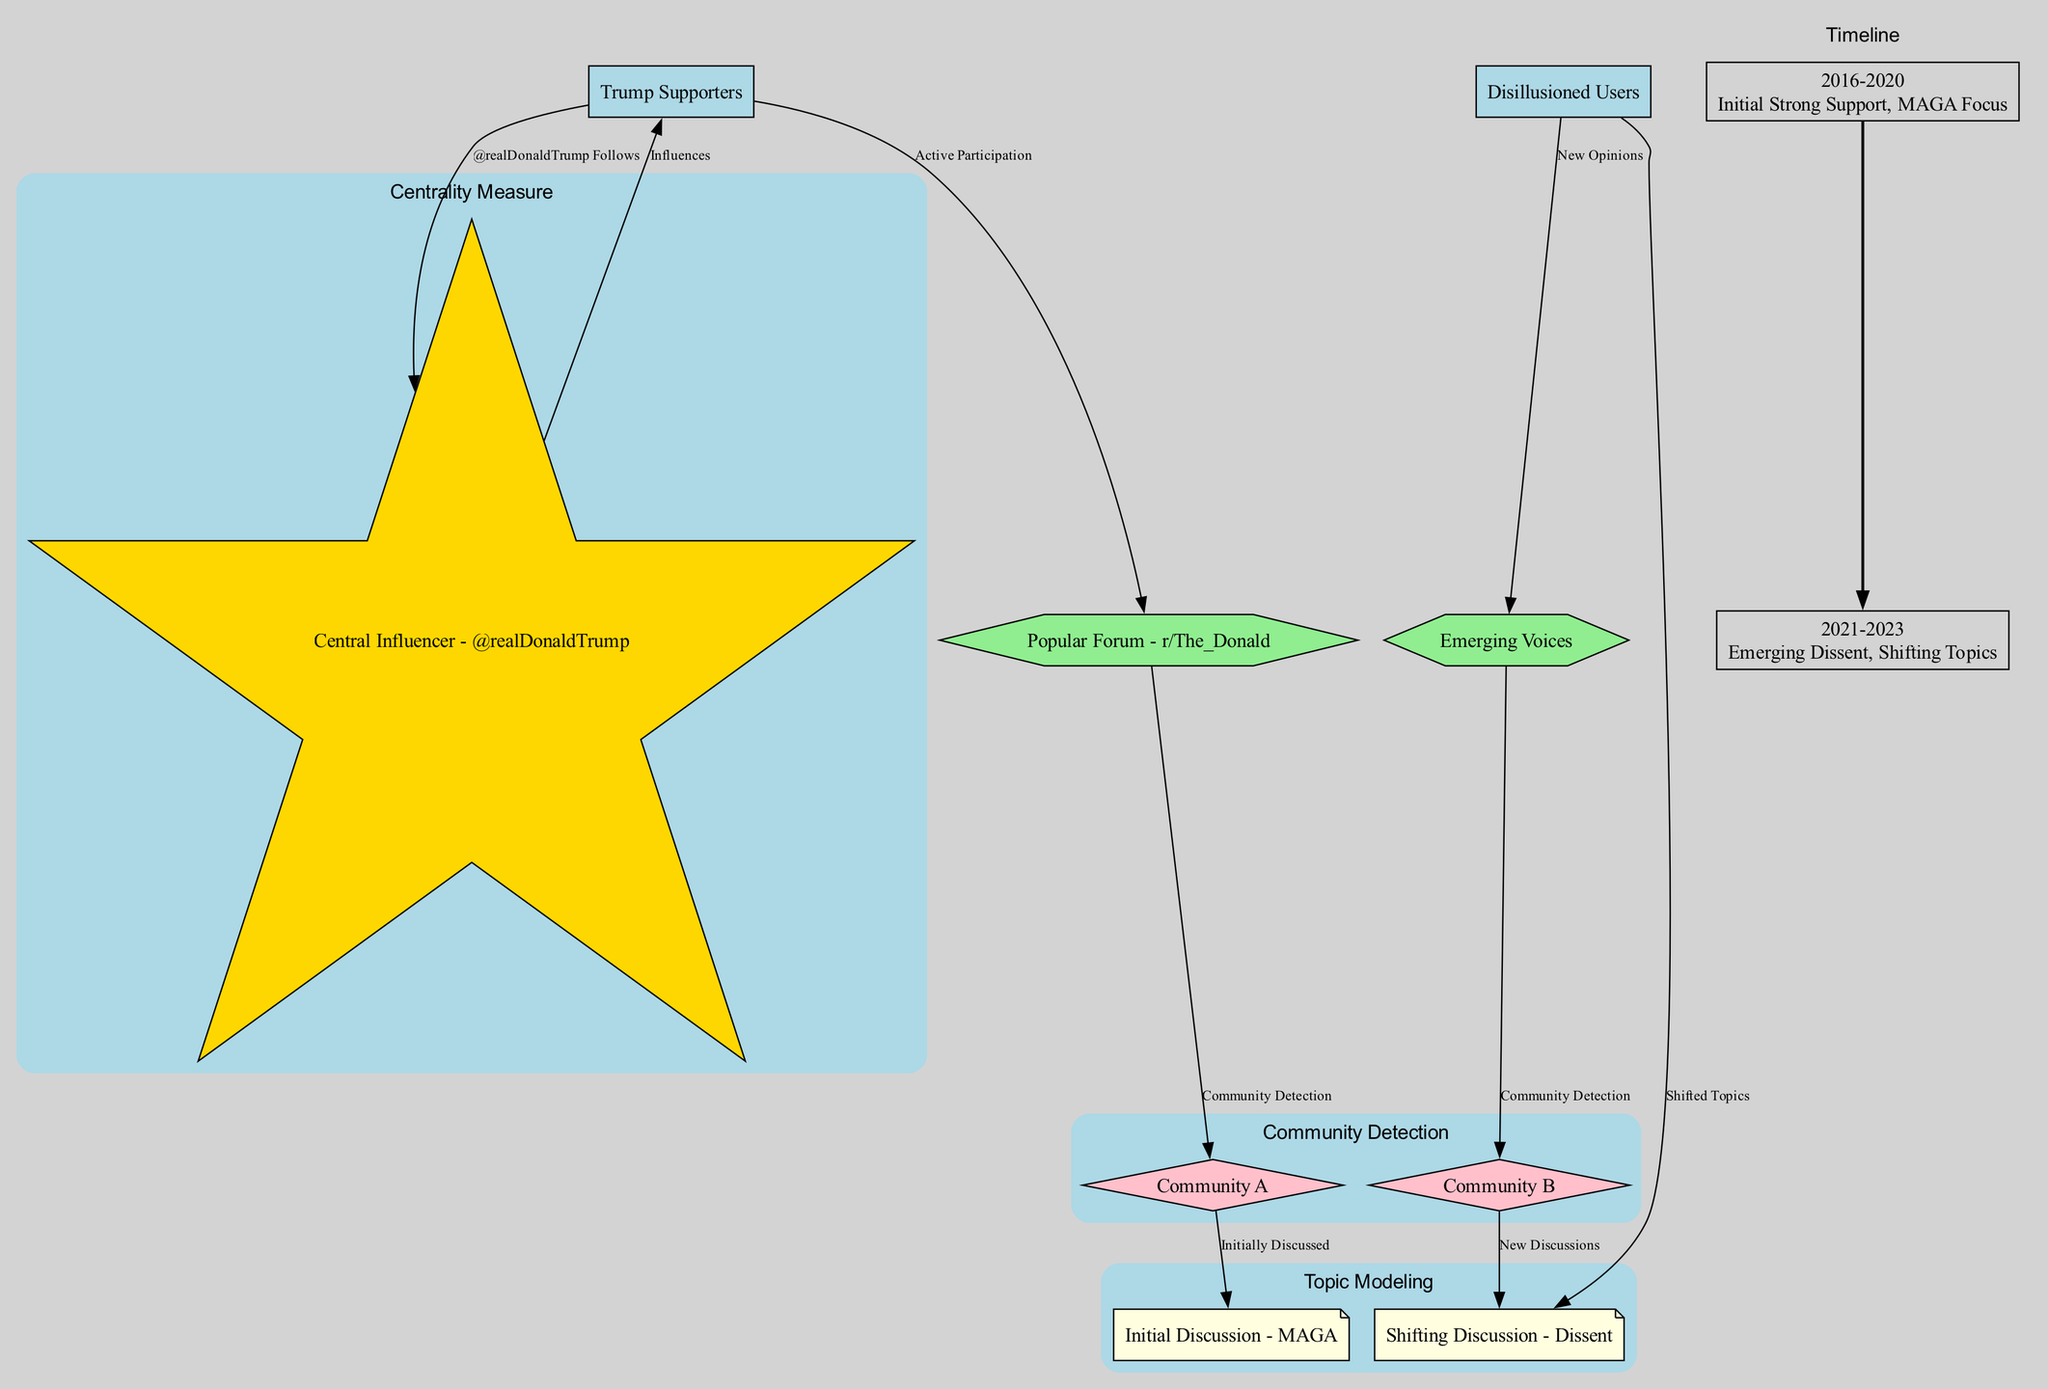What is the central influencer in this diagram? The central influencer is identified as a specific node in the diagram labeled as '@realDonaldTrump'. This is evident as there is an edge labeled 'Influences' connecting '@realDonaldTrump' to 'Trump Supporters'.
Answer: @realDonaldTrump How many nodes are in the diagram? The diagram includes a total of eight unique nodes representing different user types, communities, discussions, and influencers. By counting each distinct node listed in the data, we find there are eight.
Answer: 9 What is the label of the node connected to 'Disillusioned Users'? The node directly connected to 'Disillusioned Users' is labeled 'New Opinions'. This relationship is shown in the diagram indicating the type of connection between the two.
Answer: New Opinions What is the initial discussion topic period mentioned? The diagram specifies a timeline that includes a key period from 2016 to 2020, identified with 'MAGA Focus' as a significant discussion topic during that time.
Answer: MAGA What communities are referenced in this diagram? Two communities are referred to in the diagram, specifically labeled as 'Community A' and 'Community B', which each have connections indicating community detection.
Answer: Community A, Community B What algorithm is applied to the central influencer? The algorithm named 'Centrality Measure' is specifically applied to the node representing the central influencer '@realDonaldTrump' as denoted in the diagram’s algorithm section.
Answer: Centrality Measure Which discussion shifted toward dissent? The discussion that indicates a shift is labeled as 'Dissent'. The edge showing this flow is connected to the 'Disillusioned Users' node pointing to 'Shifted Topics', indicating this transition in conversation.
Answer: Dissent How did 'Popular Forum - r/The_Donald' relate to community detection? 'Popular Forum - r/The_Donald' has a direct relationship to 'Community A' through community detection, shown by an edge connecting the two, indicating the active community influence of the forum.
Answer: Community A In what year did the emerging dissent begin? The timeline indicates that the emerging dissent as a key event began in 2021, as stated in the key events for the period from 2021 to 2023.
Answer: 2021 